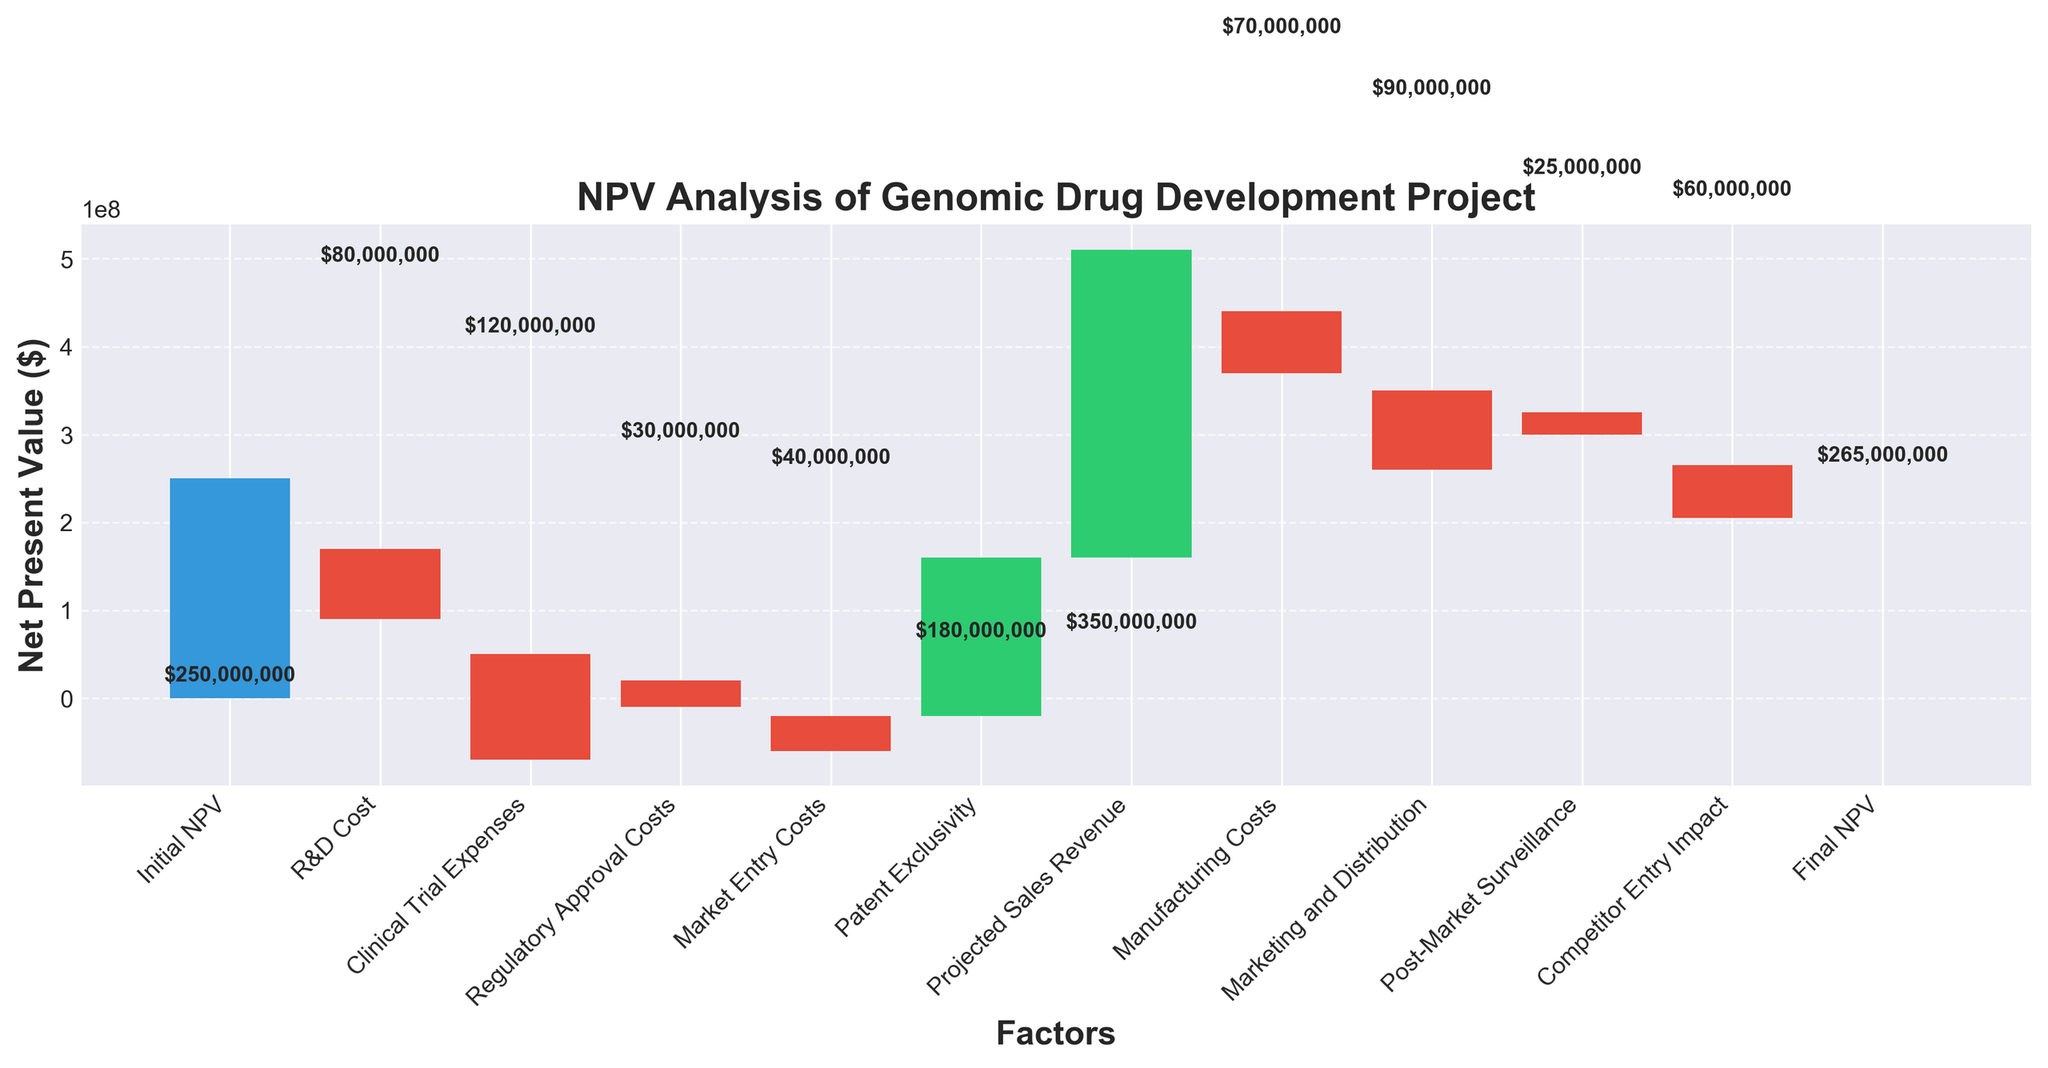What is the title of the waterfall chart? The title of the chart is located at the top and usually summarizes the main insight. The chart's title is "NPV Analysis of Genomic Drug Development Project."
Answer: NPV Analysis of Genomic Drug Development Project How many factors are impacting the NPV in this analysis? To find the number of factors, count the categories listed on the x-axis. The categories are "Initial NPV", "R&D Cost", "Clinical Trial Expenses", "Regulatory Approval Costs", "Market Entry Costs", "Patent Exclusivity", "Projected Sales Revenue", "Manufacturing Costs", "Marketing and Distribution", "Post-Market Surveillance", "Competitor Entry Impact", and "Final NPV".
Answer: 12 Which factor had the highest negative impact on the NPV? Check the bars representing negative impacts (colored in red). The "Clinical Trial Expenses" has the largest negative value of -$120,000,000, making it the highest negative impact.
Answer: Clinical Trial Expenses What is the final NPV of the genomic drug development project? The final NPV is depicted by the last value bar on the far right of the chart. It is labeled as "Final NPV" with a value of $265,000,000.
Answer: $265,000,000 What is the net impact of "Patent Exclusivity" and "Competitor Entry Impact" combined? Add their values. "Patent Exclusivity" is +$180,000,000 and "Competitor Entry Impact" is -$60,000,000. The combined impact is $180,000,000 + (-$60,000,000) = $120,000,000.
Answer: $120,000,000 Which factor contributed most positively to the NPV? Look at the green bars, which represent positive impacts. The "Projected Sales Revenue" has the highest value of +$350,000,000, making it the largest positive contributor.
Answer: Projected Sales Revenue What is the cumulative cost of "R&D Cost", "Clinical Trial Expenses", and "Regulatory Approval Costs"? Add their values. "R&D Cost" is -$80,000,000, "Clinical Trial Expenses" is -$120,000,000, and "Regulatory Approval Costs" is -$30,000,000. The cumulative cost is -$80,000,000 + (-$120,000,000) + (-$30,000,000) = -$230,000,000.
Answer: -$230,000,000 How does the "Initial NPV" compare to the "Final NPV"? Subtract the "Initial NPV" from the "Final NPV". Initial NPV is $250,000,000 and Final NPV is $265,000,000. The difference is $265,000,000 - $250,000,000 = $15,000,000. So, the Final NPV is higher by $15,000,000.
Answer: Final NPV is higher by $15,000,000 What is the total value contributed by factors labeled in green bars? Sum the values represented by green bars. "Patent Exclusivity" is +$180,000,000 and "Projected Sales Revenue" is +$350,000,000. Total value is $180,000,000 + $350,000,000 = $530,000,000.
Answer: $530,000,000 